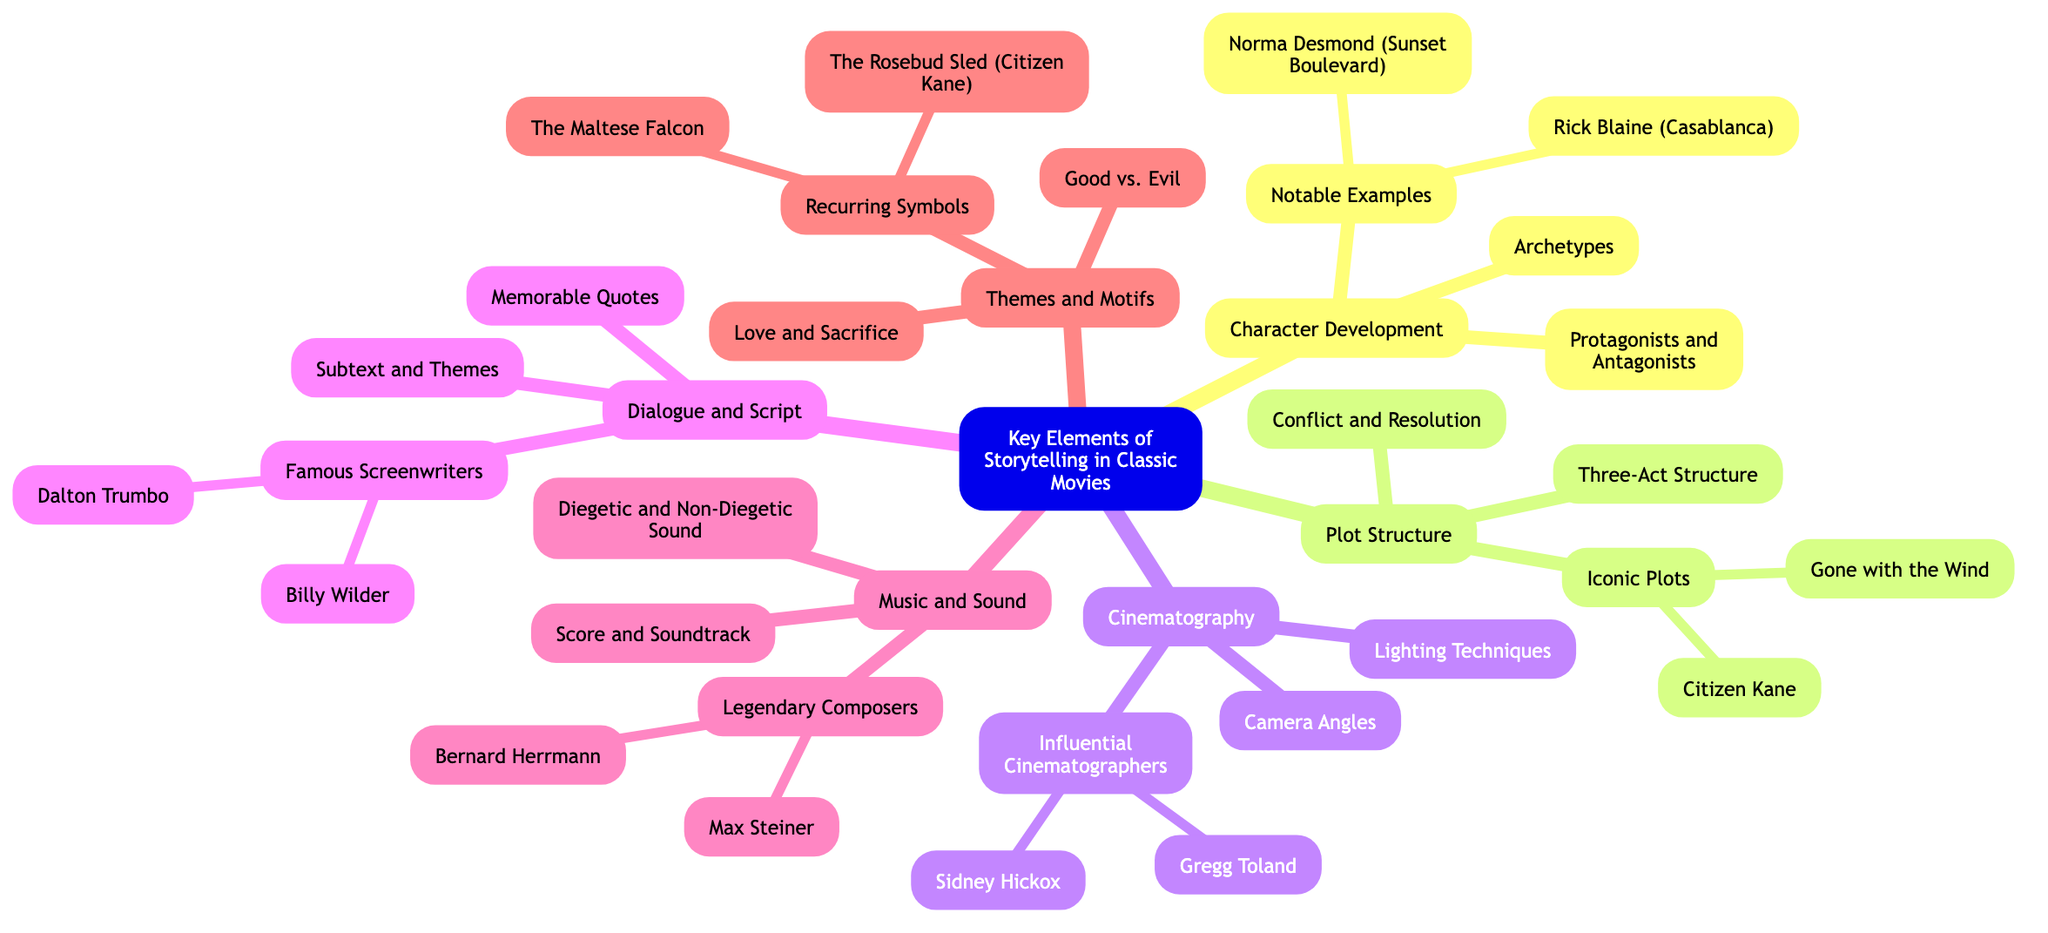What is the main topic of the mind map? The primary focus of the diagram is clearly stated at the center, which is "Key Elements of Storytelling in Classic Movies."
Answer: Key Elements of Storytelling in Classic Movies How many branches does the mind map have? By counting the main categories stemming from the central topic, there are a total of six branches: Character Development, Plot Structure, Cinematography, Dialogue and Script, Music and Sound, and Themes and Motifs.
Answer: 6 Which character is an example of a notable protagonist? We look under the branch for "Notable Examples" within "Character Development" to find Rick Blaine mentioned here as a notable protagonist.
Answer: Rick Blaine (Casablanca) What plot structure is emphasized in the mind map? The second branch named "Plot Structure" highlights the "Three-Act Structure" specifically, which is a common narrative framework in classic storytelling.
Answer: Three-Act Structure Which cinematic technique involves manipulating light? In the "Cinematography" branch, the subtopic that deals specifically with light manipulation is "Lighting Techniques."
Answer: Lighting Techniques Who is listed as a legendary composer? Under the "Music and Sound" branch, "Legendary Composers" includes Bernard Herrmann as one notable figure recognized for his contributions to film scoring.
Answer: Bernard Herrmann What common theme is identified in the mind map? The branch labeled "Themes and Motifs" identifies "Love and Sacrifice" as a recurring theme, showcasing its relevance in classic films.
Answer: Love and Sacrifice Which screenwriter is associated with memorable quotes? Under the "Dialogue and Script" branch, "Famous Screenwriters" mentions Billy Wilder as a notable writer known for his impactful dialogue, including memorable quotes.
Answer: Billy Wilder How many subtopics does the "Music and Sound" branch have? Count the subtopics listed under the "Music and Sound" branch, which includes three specific areas: "Score and Soundtrack," "Diegetic and Non-Diegetic Sound," and "Legendary Composers." Thus, the total is three.
Answer: 3 What symbolizes 'the rosebud sled' in classic literature? Within the "Recurring Symbols" under "Themes and Motifs," the "Rosebud Sled" is specifically identified as a notable symbol in the film "Citizen Kane."
Answer: The Rosebud Sled (Citizen Kane) 